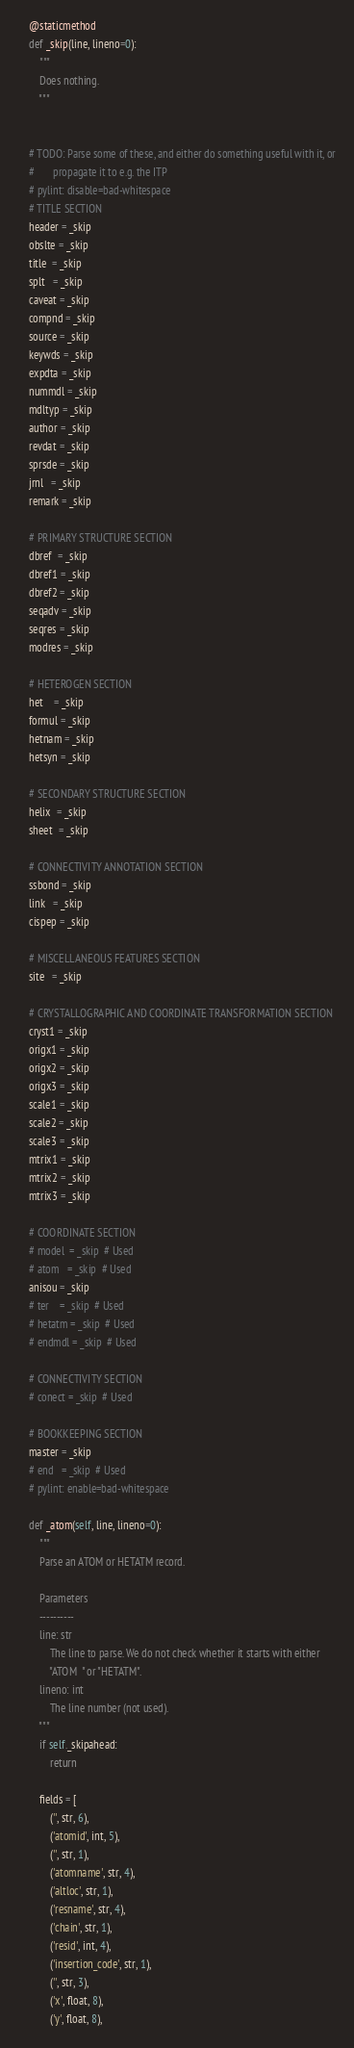<code> <loc_0><loc_0><loc_500><loc_500><_Python_>
    @staticmethod
    def _skip(line, lineno=0):
        """
        Does nothing.
        """


    # TODO: Parse some of these, and either do something useful with it, or
    #       propagate it to e.g. the ITP
    # pylint: disable=bad-whitespace
    # TITLE SECTION
    header = _skip
    obslte = _skip
    title  = _skip
    splt   = _skip
    caveat = _skip
    compnd = _skip
    source = _skip
    keywds = _skip
    expdta = _skip
    nummdl = _skip
    mdltyp = _skip
    author = _skip
    revdat = _skip
    sprsde = _skip
    jrnl   = _skip
    remark = _skip

    # PRIMARY STRUCTURE SECTION
    dbref  = _skip
    dbref1 = _skip
    dbref2 = _skip
    seqadv = _skip
    seqres = _skip
    modres = _skip

    # HETEROGEN SECTION
    het    = _skip
    formul = _skip
    hetnam = _skip
    hetsyn = _skip

    # SECONDARY STRUCTURE SECTION
    helix  = _skip
    sheet  = _skip

    # CONNECTIVITY ANNOTATION SECTION
    ssbond = _skip
    link   = _skip
    cispep = _skip

    # MISCELLANEOUS FEATURES SECTION
    site   = _skip

    # CRYSTALLOGRAPHIC AND COORDINATE TRANSFORMATION SECTION
    cryst1 = _skip
    origx1 = _skip
    origx2 = _skip
    origx3 = _skip
    scale1 = _skip
    scale2 = _skip
    scale3 = _skip
    mtrix1 = _skip
    mtrix2 = _skip
    mtrix3 = _skip

    # COORDINATE SECTION
    # model  = _skip  # Used
    # atom   = _skip  # Used
    anisou = _skip
    # ter    = _skip  # Used
    # hetatm = _skip  # Used
    # endmdl = _skip  # Used

    # CONNECTIVITY SECTION
    # conect = _skip  # Used

    # BOOKKEEPING SECTION
    master = _skip
    # end   = _skip  # Used
    # pylint: enable=bad-whitespace

    def _atom(self, line, lineno=0):
        """
        Parse an ATOM or HETATM record.

        Parameters
        ----------
        line: str
            The line to parse. We do not check whether it starts with either
            "ATOM  " or "HETATM".
        lineno: int
            The line number (not used).
        """
        if self._skipahead:
            return

        fields = [
            ('', str, 6),
            ('atomid', int, 5),
            ('', str, 1),
            ('atomname', str, 4),
            ('altloc', str, 1),
            ('resname', str, 4),
            ('chain', str, 1),
            ('resid', int, 4),
            ('insertion_code', str, 1),
            ('', str, 3),
            ('x', float, 8),
            ('y', float, 8),</code> 